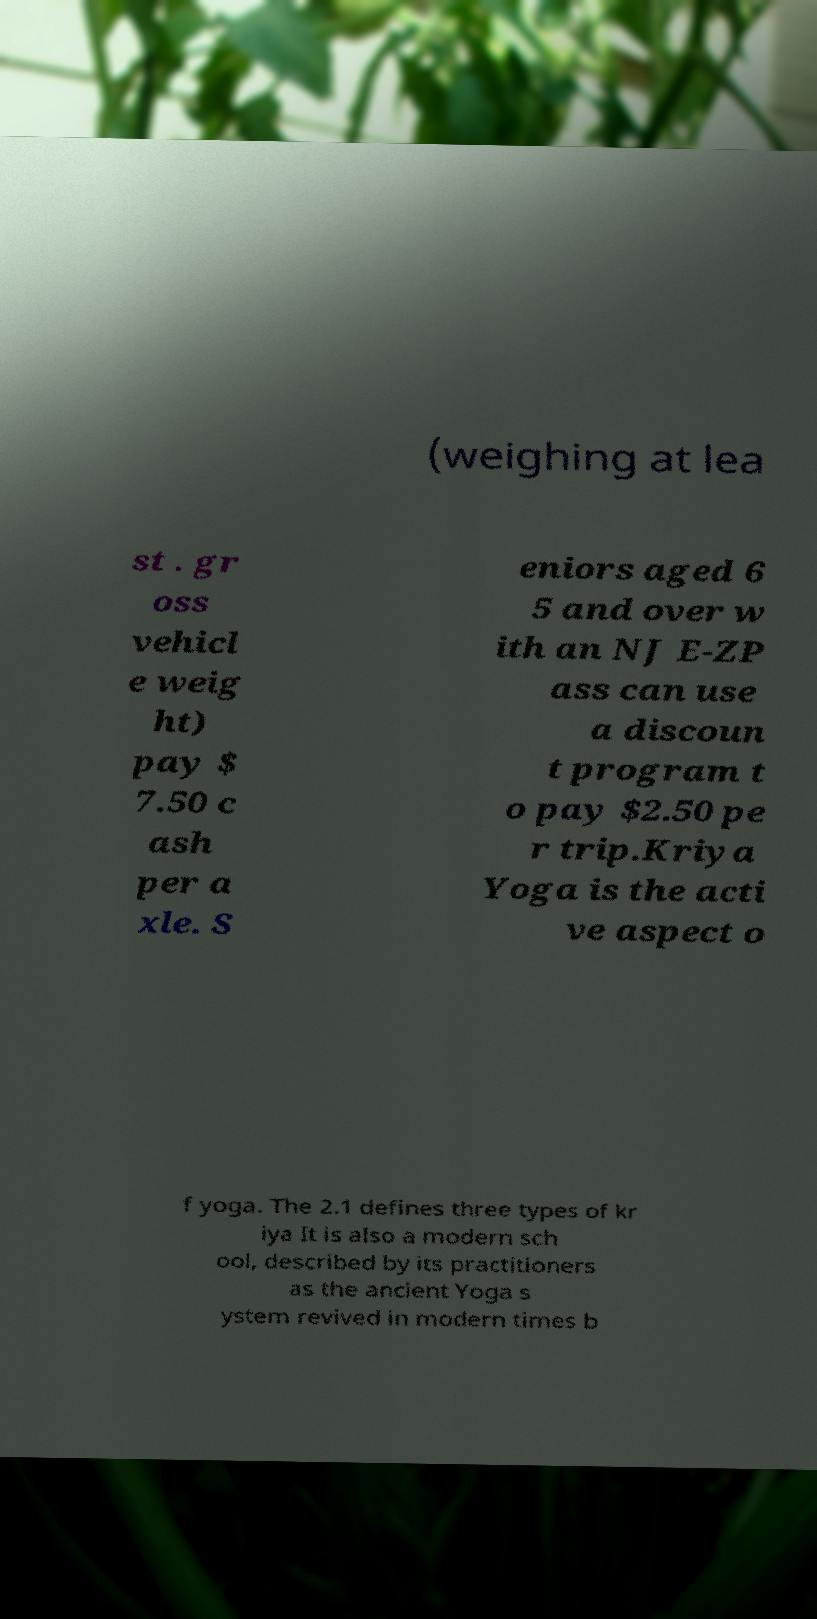What messages or text are displayed in this image? I need them in a readable, typed format. (weighing at lea st . gr oss vehicl e weig ht) pay $ 7.50 c ash per a xle. S eniors aged 6 5 and over w ith an NJ E-ZP ass can use a discoun t program t o pay $2.50 pe r trip.Kriya Yoga is the acti ve aspect o f yoga. The 2.1 defines three types of kr iya It is also a modern sch ool, described by its practitioners as the ancient Yoga s ystem revived in modern times b 